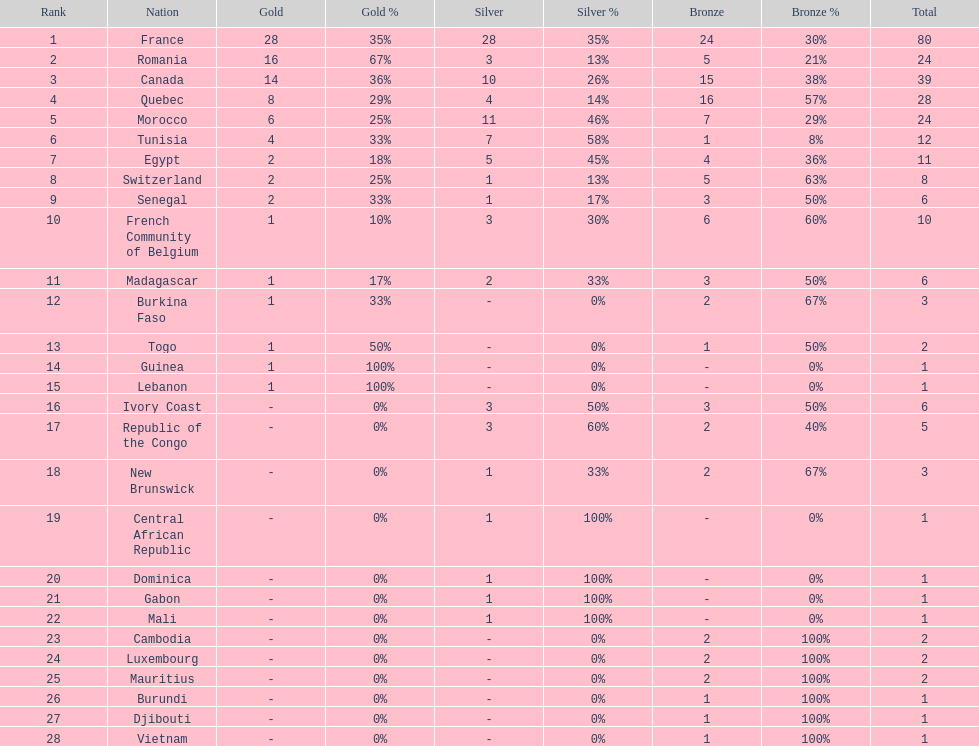What was the total medal count of switzerland? 8. 